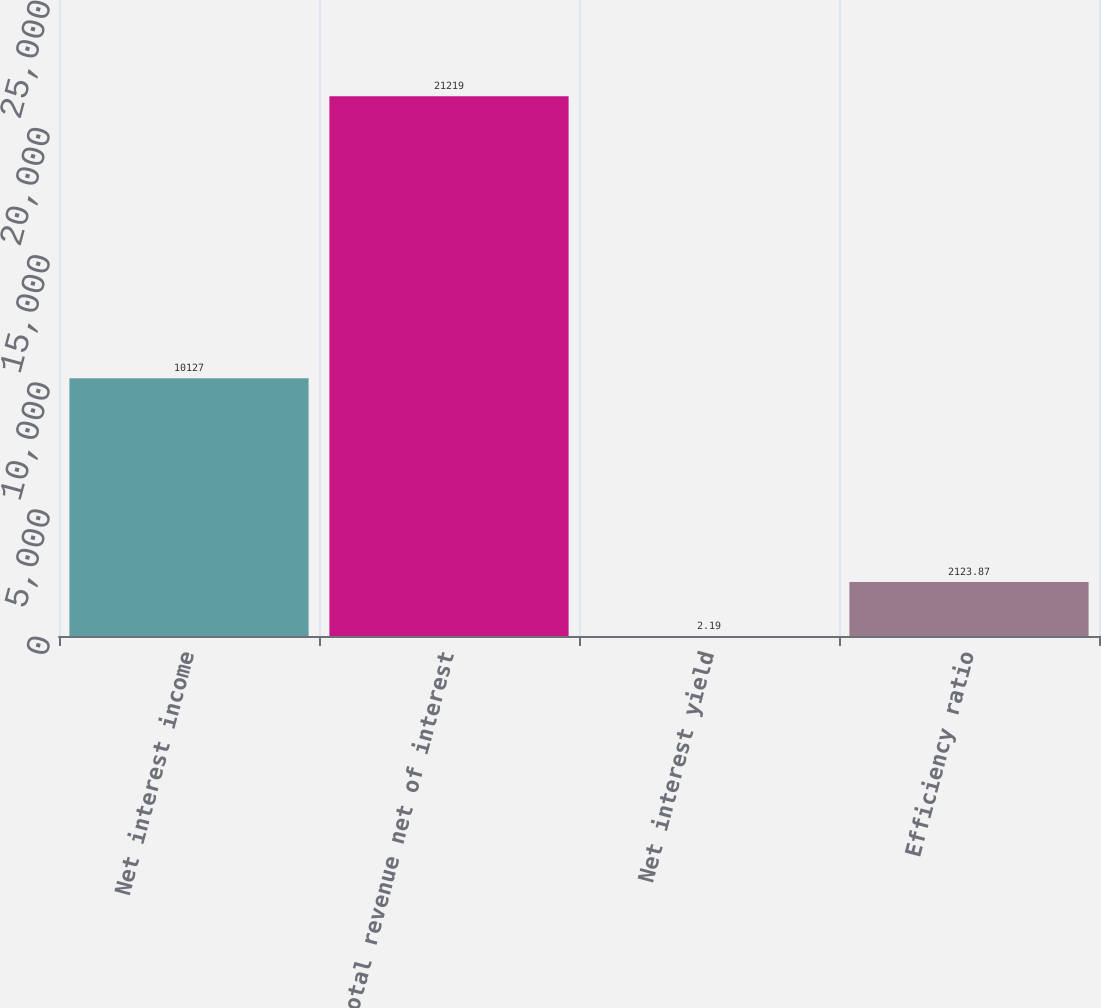<chart> <loc_0><loc_0><loc_500><loc_500><bar_chart><fcel>Net interest income<fcel>Total revenue net of interest<fcel>Net interest yield<fcel>Efficiency ratio<nl><fcel>10127<fcel>21219<fcel>2.19<fcel>2123.87<nl></chart> 